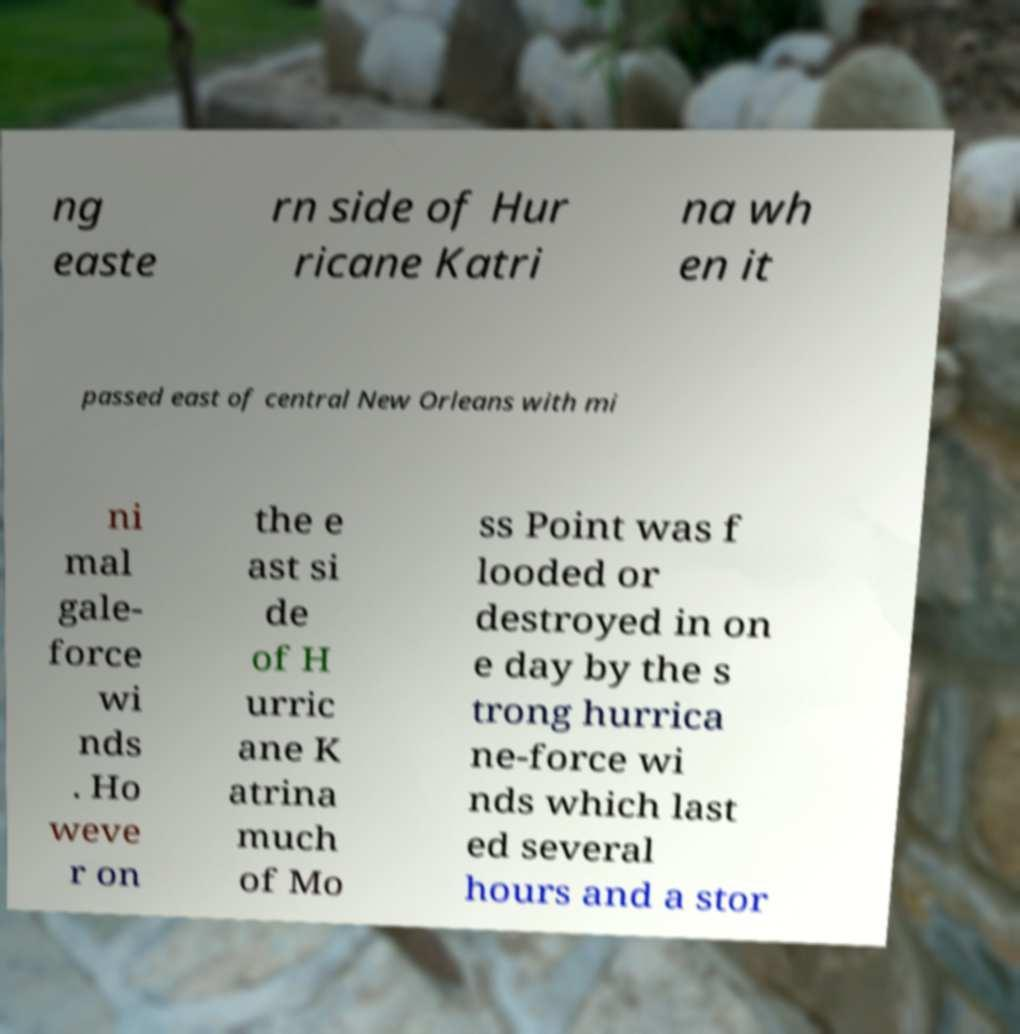Can you read and provide the text displayed in the image?This photo seems to have some interesting text. Can you extract and type it out for me? ng easte rn side of Hur ricane Katri na wh en it passed east of central New Orleans with mi ni mal gale- force wi nds . Ho weve r on the e ast si de of H urric ane K atrina much of Mo ss Point was f looded or destroyed in on e day by the s trong hurrica ne-force wi nds which last ed several hours and a stor 